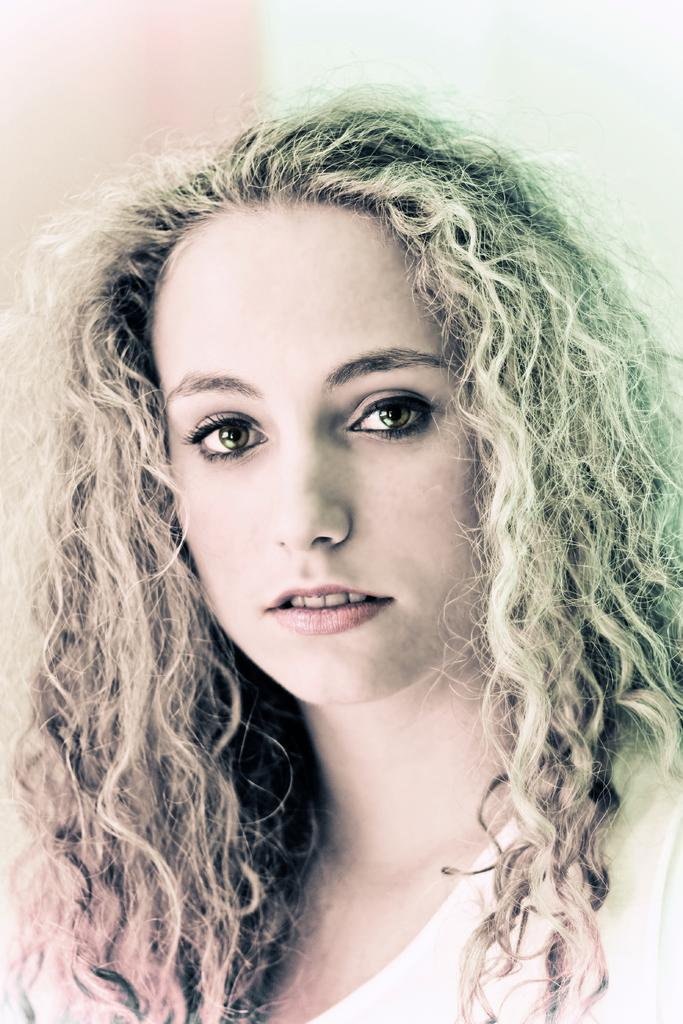Who is the main subject in the image? There is a girl in the image. Where is the girl positioned in the image? The girl is in the center of the image. What type of insect can be seen using its fang to climb the boundary in the image? There is no insect or boundary present in the image, and therefore no such activity can be observed. 